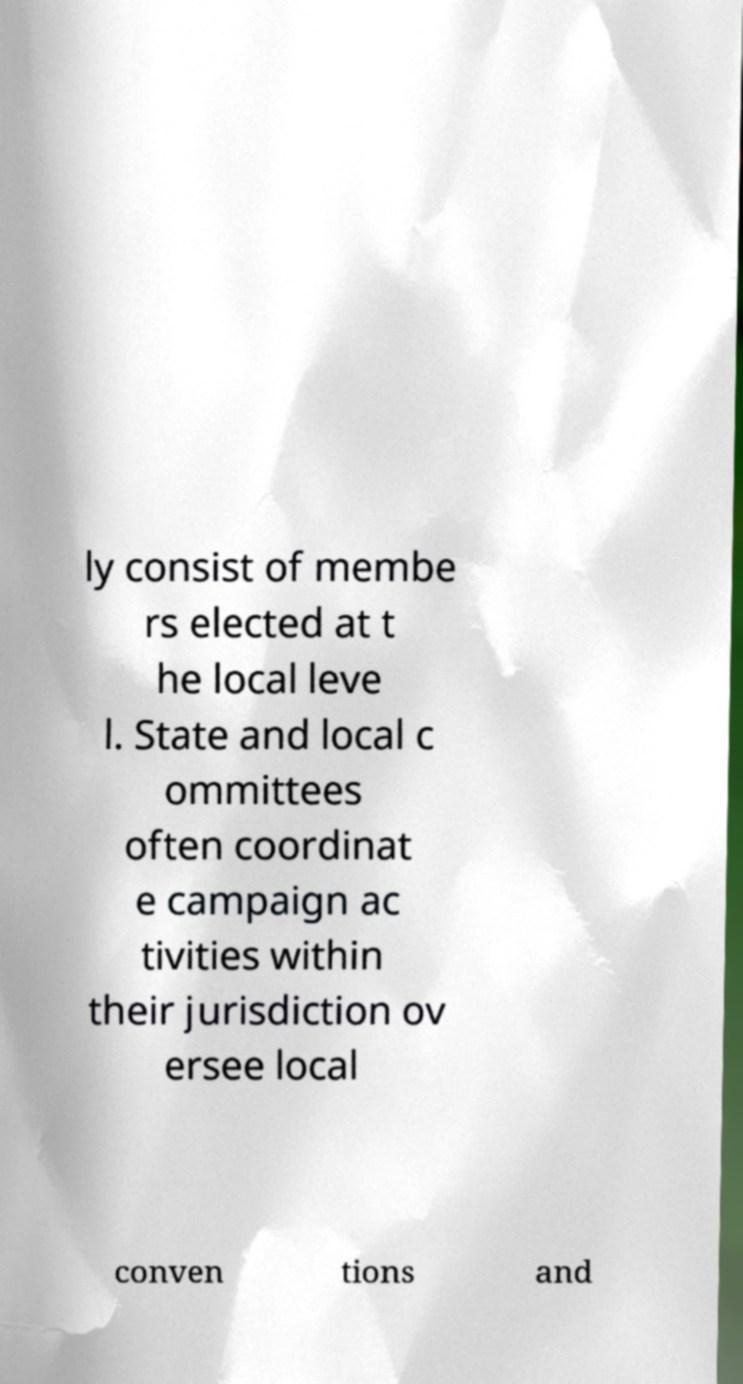Please identify and transcribe the text found in this image. ly consist of membe rs elected at t he local leve l. State and local c ommittees often coordinat e campaign ac tivities within their jurisdiction ov ersee local conven tions and 